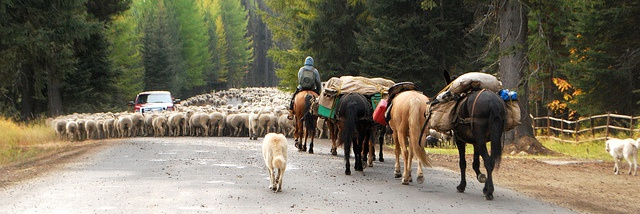Describe the objects in this image and their specific colors. I can see sheep in black, ivory, gray, darkgray, and tan tones, horse in black, gray, and maroon tones, horse in black, gray, maroon, brown, and tan tones, horse in black, gray, and maroon tones, and horse in black, maroon, and gray tones in this image. 